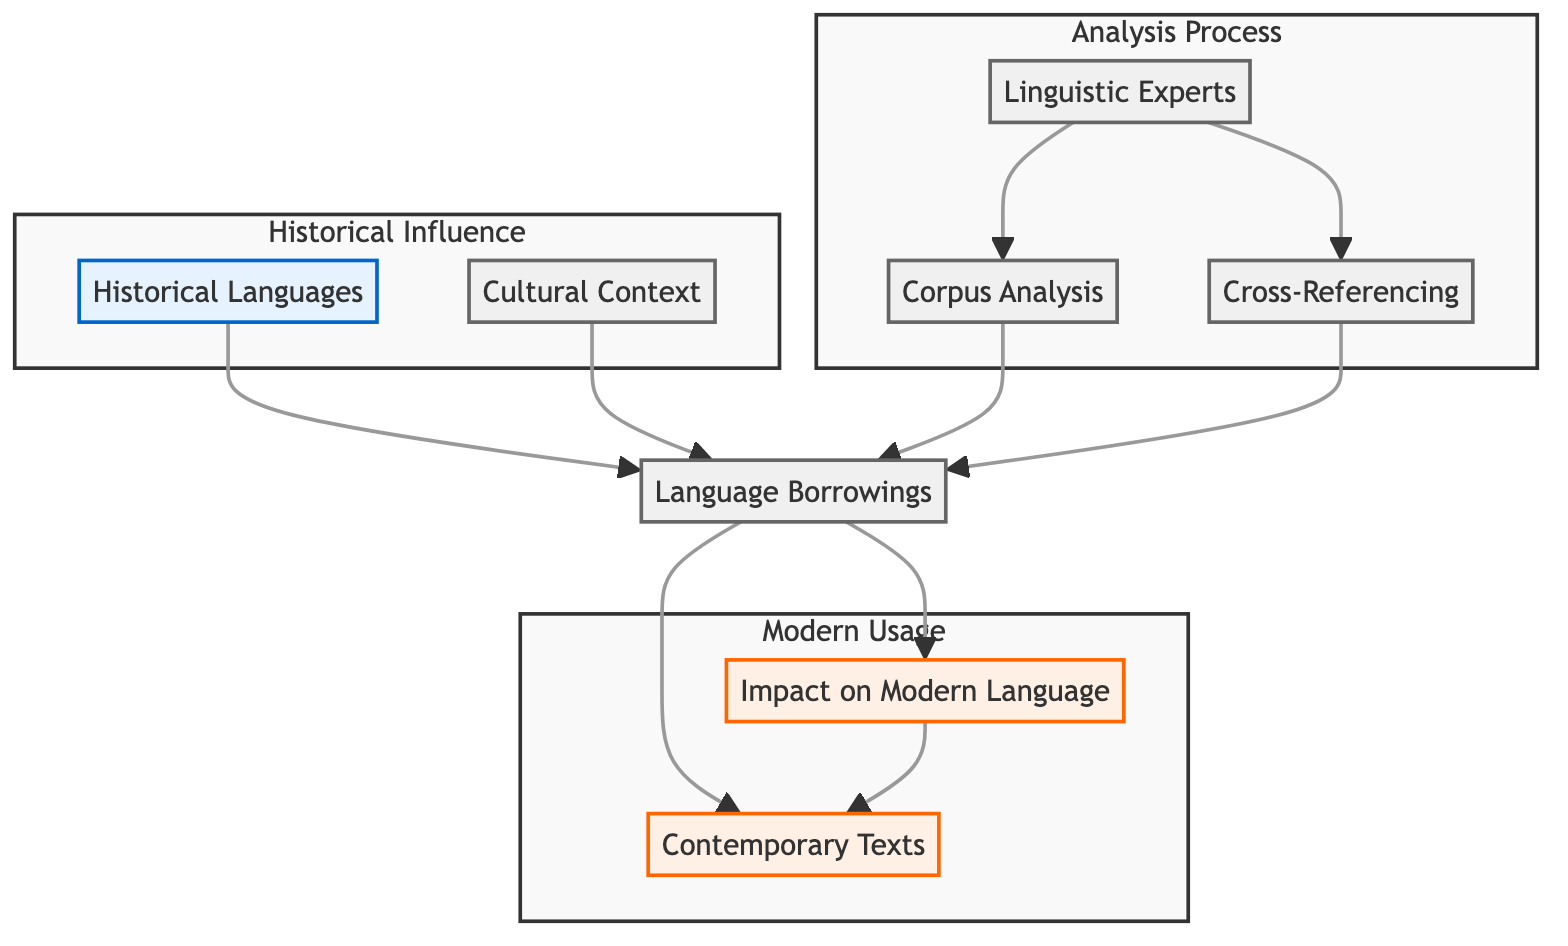What are the key components in the diagram? The diagram contains eight key components: Contemporary Texts, Language Borrowings, Historical Languages, Cultural Context, Linguistic Experts, Corpus Analysis, Cross-Referencing, and Impact on Modern Language.
Answer: Eight Which component influences Language Borrowings? Language Borrowings are influenced by Historical Languages and Cultural Context as depicted in the arrows pointing towards it from these two components.
Answer: Historical Languages, Cultural Context How many components are classified under Modern Usage in the diagram? The Modern Usage subgraph includes two components: Contemporary Texts and Impact on Modern Language, showcasing the elements that represent modern language applications.
Answer: Two What is the final output of Language Borrowings according to the diagram? The final output of Language Borrowings leads to the Impact on Modern Language, indicating the effect of borrowed terms on contemporary language usage.
Answer: Impact on Modern Language Which element is analyzed by Linguistic Experts? Linguistic Experts analyze both Corpus Analysis and Cross-Referencing, which are processes utilized to examine language borrowings in texts.
Answer: Corpus Analysis, Cross-Referencing What is the relationship between Corpus Analysis and Language Borrowings? Corpus Analysis quantifies instances of language borrowings, meaning it links back to Language Borrowings as it provides a method to analyze and interpret them.
Answer: Quantifies How does Historical Languages relate to Contemporary Texts? Historical Languages contribute to Language Borrowings, which in turn influences Contemporary Texts, showing an indirect relationship affecting modern expressions.
Answer: Indirect influence Which components form the Analysis Process in the diagram? The Analysis Process is formed by Linguistic Experts, Corpus Analysis, and Cross-Referencing, encapsulating the methodologies used to study borrowings.
Answer: Linguistic Experts, Corpus Analysis, Cross-Referencing What is the primary flow direction in the diagram? The primary flow direction moves from Historical Languages and Cultural Context to Language Borrowings, then toward Contemporary Texts and Impact on Modern Language, indicating a bottom-up approach for analyzing borrowings.
Answer: Bottom-Up 